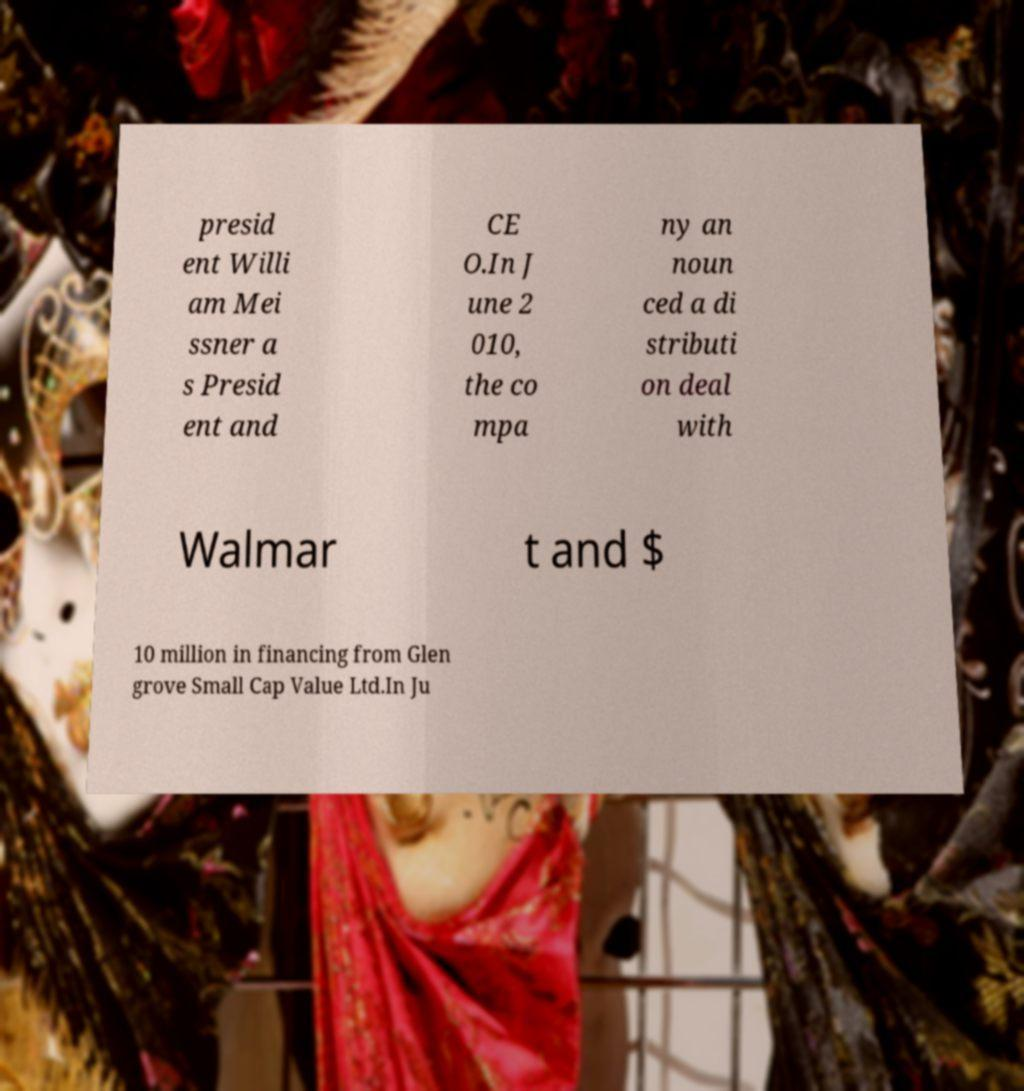Could you assist in decoding the text presented in this image and type it out clearly? presid ent Willi am Mei ssner a s Presid ent and CE O.In J une 2 010, the co mpa ny an noun ced a di stributi on deal with Walmar t and $ 10 million in financing from Glen grove Small Cap Value Ltd.In Ju 